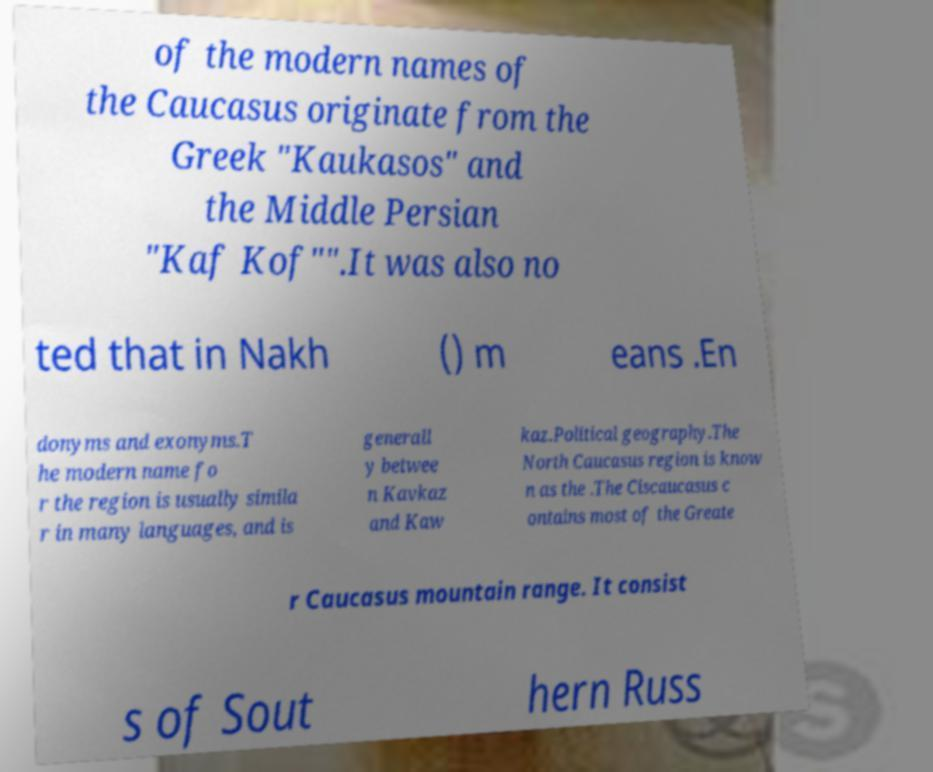Can you accurately transcribe the text from the provided image for me? of the modern names of the Caucasus originate from the Greek "Kaukasos" and the Middle Persian "Kaf Kof"".It was also no ted that in Nakh () m eans .En donyms and exonyms.T he modern name fo r the region is usually simila r in many languages, and is generall y betwee n Kavkaz and Kaw kaz.Political geography.The North Caucasus region is know n as the .The Ciscaucasus c ontains most of the Greate r Caucasus mountain range. It consist s of Sout hern Russ 